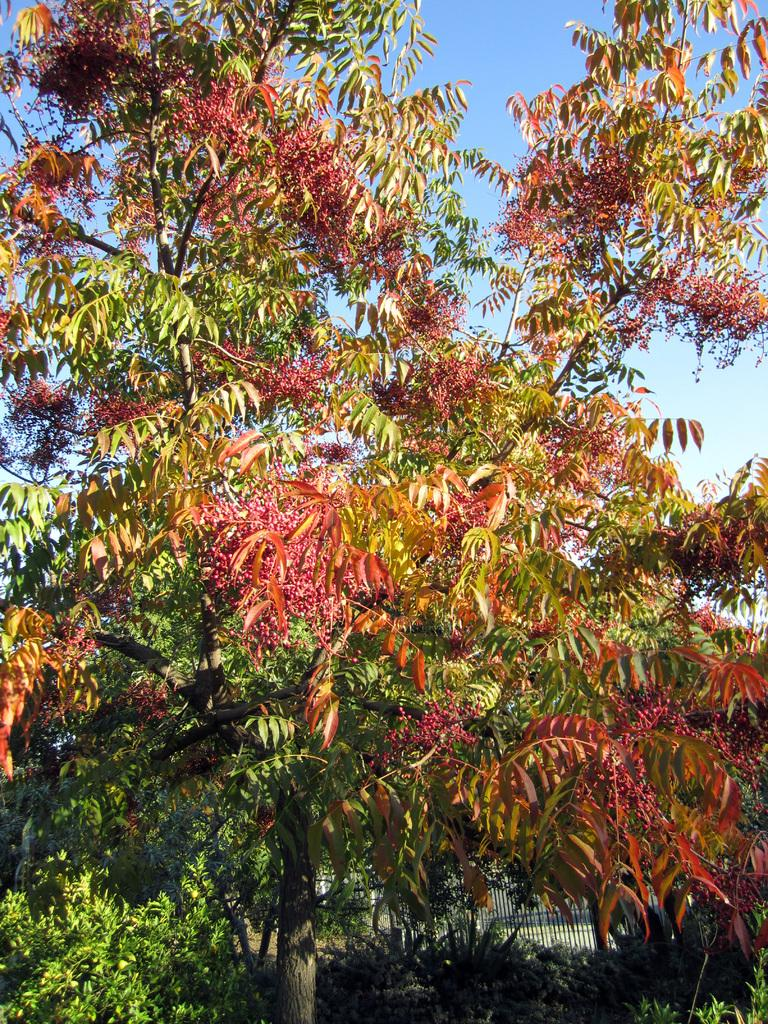What type of vegetation can be seen in the image? There are trees and shrubs in the image. What part of the natural environment is visible in the image? The sky is visible in the background of the image. Can you describe the vegetation in more detail? The trees and shrubs in the image are part of the natural environment. What type of street can be seen in the image? There is no street present in the image; it features trees, shrubs, and the sky. What type of building is visible in the image? There is no building present in the image; it features trees, shrubs, and the sky. 